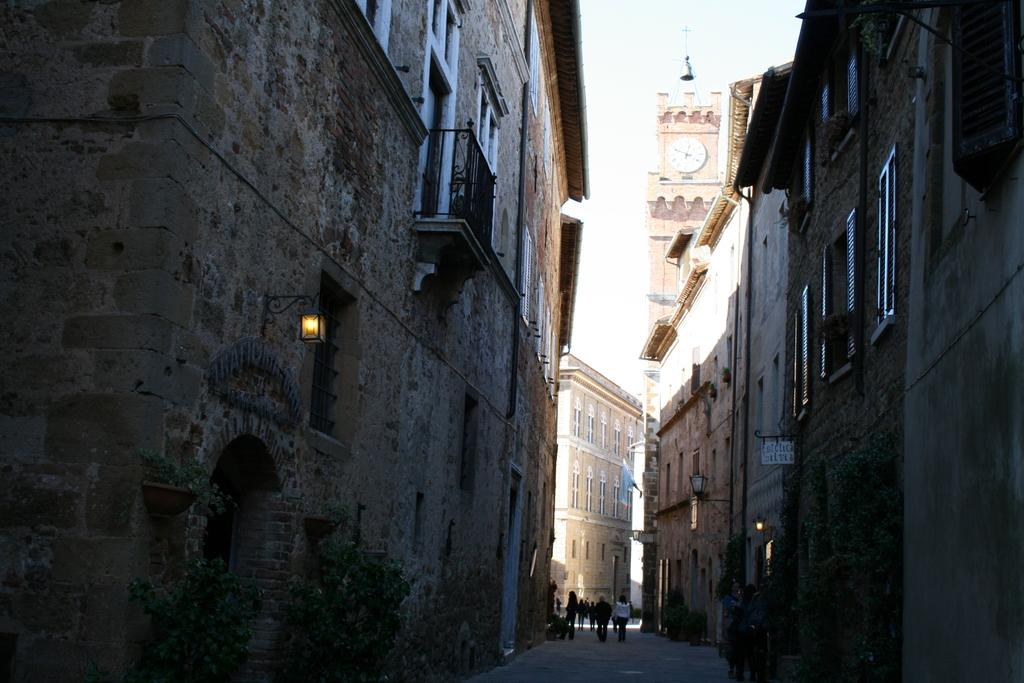What type of structures can be seen in the image? There are buildings in the image. Are there any living beings present in the image? Yes, there are people in the image. What can be found on the wall in the image? Lights are present on the wall. What type of architectural feature is visible in the image? There is a clock tower in the image. What is the price of the kitty in the image? There is no kitty present in the image, so it is not possible to determine its price. 